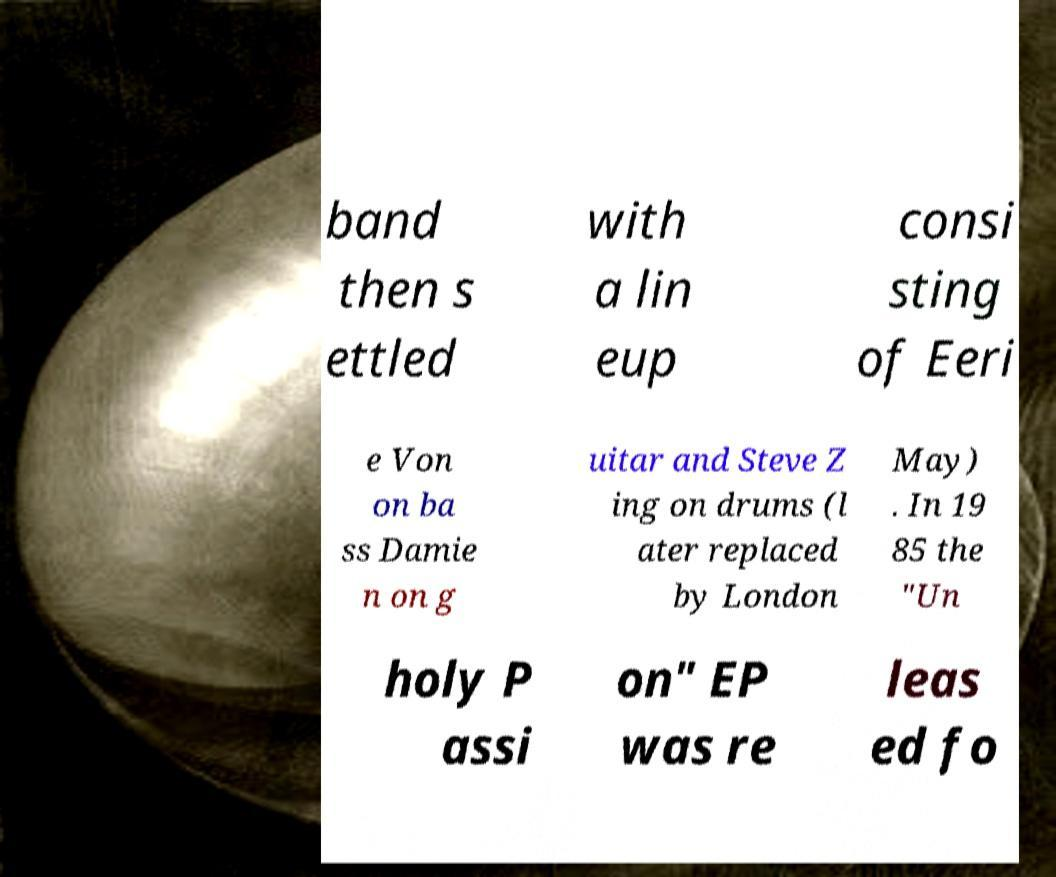Please read and relay the text visible in this image. What does it say? band then s ettled with a lin eup consi sting of Eeri e Von on ba ss Damie n on g uitar and Steve Z ing on drums (l ater replaced by London May) . In 19 85 the "Un holy P assi on" EP was re leas ed fo 